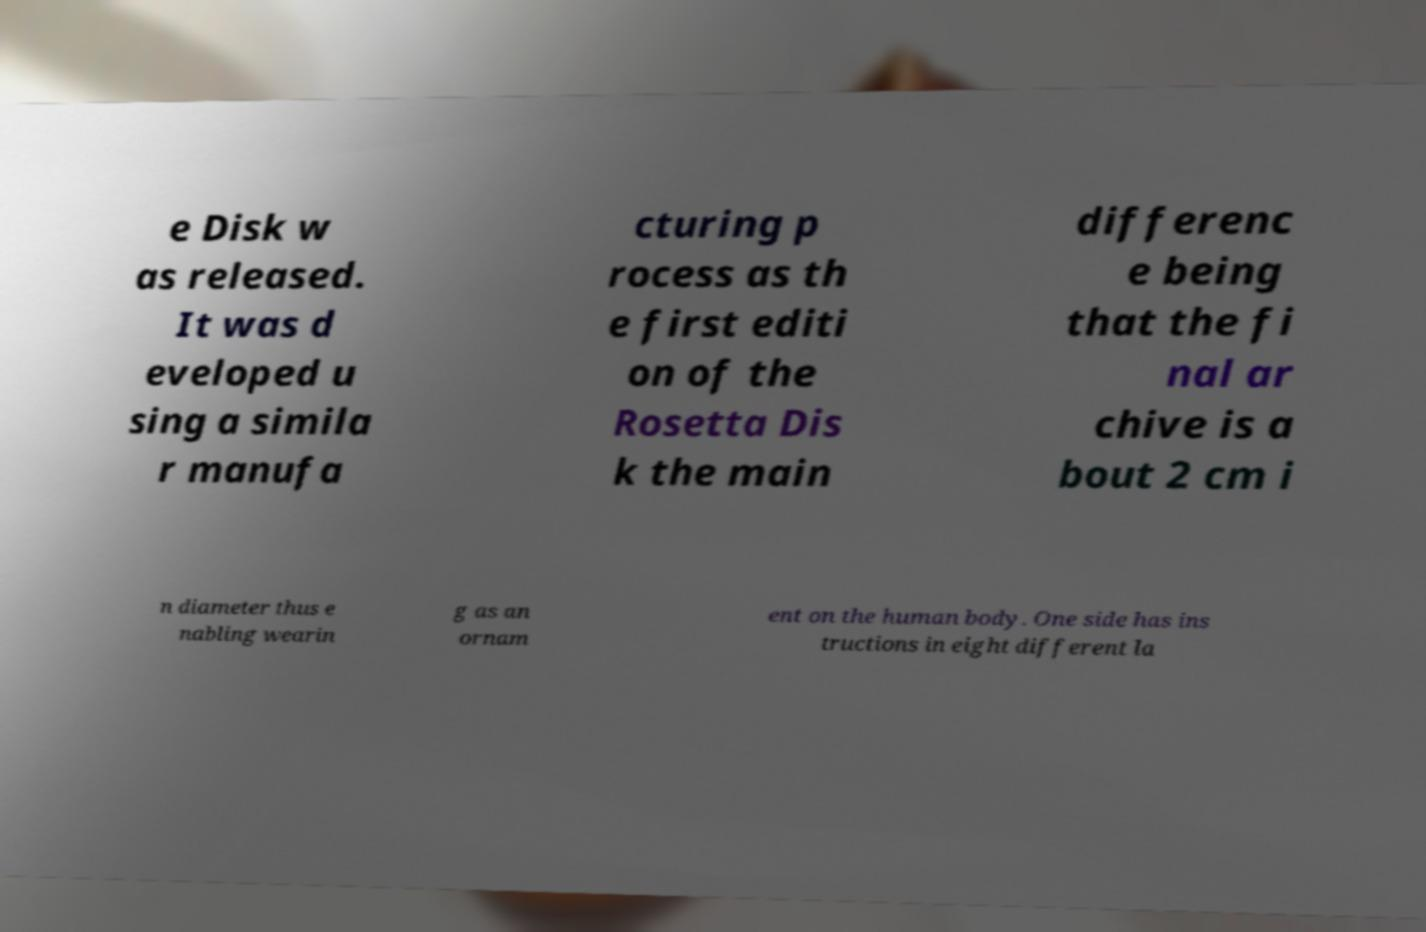I need the written content from this picture converted into text. Can you do that? e Disk w as released. It was d eveloped u sing a simila r manufa cturing p rocess as th e first editi on of the Rosetta Dis k the main differenc e being that the fi nal ar chive is a bout 2 cm i n diameter thus e nabling wearin g as an ornam ent on the human body. One side has ins tructions in eight different la 